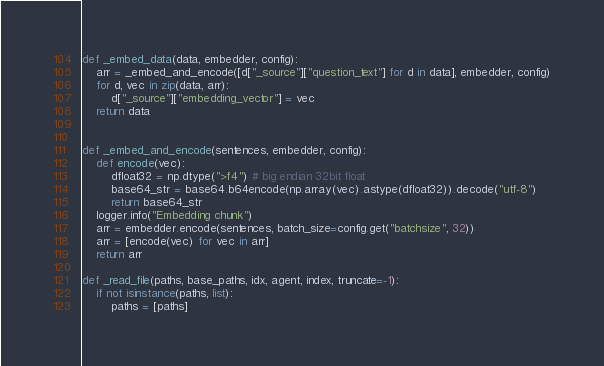Convert code to text. <code><loc_0><loc_0><loc_500><loc_500><_Python_>

def _embed_data(data, embedder, config):
    arr = _embed_and_encode([d["_source"]["question_text"] for d in data], embedder, config)
    for d, vec in zip(data, arr):
        d["_source"]["embedding_vector"] = vec
    return data


def _embed_and_encode(sentences, embedder, config):
    def encode(vec):
        dfloat32 = np.dtype(">f4") # big endian 32bit float
        base64_str = base64.b64encode(np.array(vec).astype(dfloat32)).decode("utf-8")
        return base64_str
    logger.info("Embedding chunk")
    arr = embedder.encode(sentences, batch_size=config.get("batchsize", 32))
    arr = [encode(vec) for vec in arr]
    return arr

def _read_file(paths, base_paths, idx, agent, index, truncate=-1):
    if not isinstance(paths, list):
        paths = [paths]</code> 